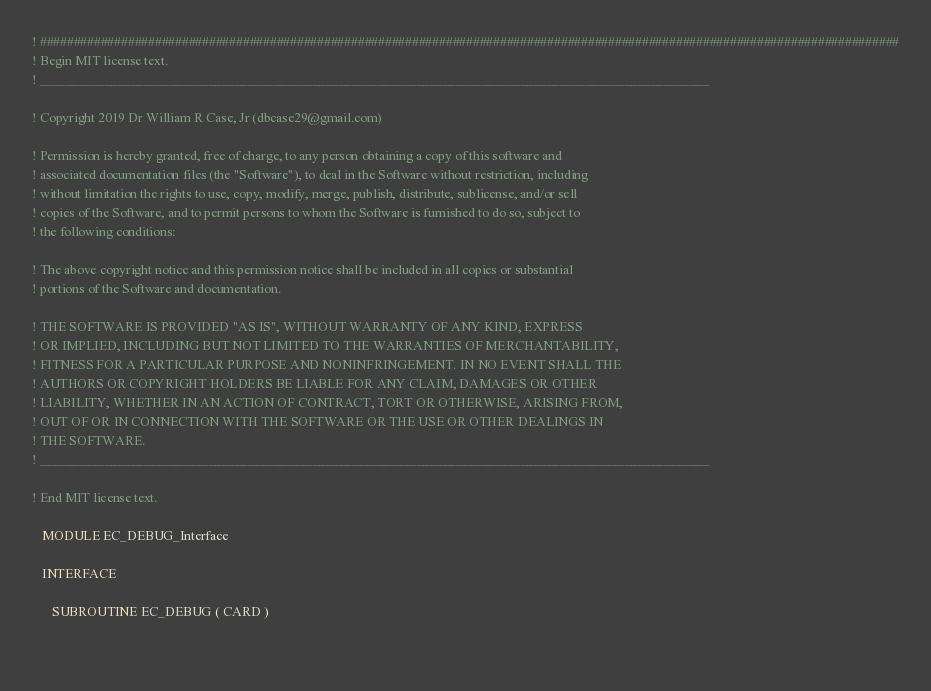Convert code to text. <code><loc_0><loc_0><loc_500><loc_500><_FORTRAN_>! ###############################################################################################################################
! Begin MIT license text.                                                                                    
! _______________________________________________________________________________________________________
                                                                                                         
! Copyright 2019 Dr William R Case, Jr (dbcase29@gmail.com)                                              
                                                                                                         
! Permission is hereby granted, free of charge, to any person obtaining a copy of this software and      
! associated documentation files (the "Software"), to deal in the Software without restriction, including
! without limitation the rights to use, copy, modify, merge, publish, distribute, sublicense, and/or sell
! copies of the Software, and to permit persons to whom the Software is furnished to do so, subject to   
! the following conditions:                                                                              
                                                                                                         
! The above copyright notice and this permission notice shall be included in all copies or substantial   
! portions of the Software and documentation.                                                                              
                                                                                                         
! THE SOFTWARE IS PROVIDED "AS IS", WITHOUT WARRANTY OF ANY KIND, EXPRESS                                
! OR IMPLIED, INCLUDING BUT NOT LIMITED TO THE WARRANTIES OF MERCHANTABILITY,                            
! FITNESS FOR A PARTICULAR PURPOSE AND NONINFRINGEMENT. IN NO EVENT SHALL THE                            
! AUTHORS OR COPYRIGHT HOLDERS BE LIABLE FOR ANY CLAIM, DAMAGES OR OTHER                                 
! LIABILITY, WHETHER IN AN ACTION OF CONTRACT, TORT OR OTHERWISE, ARISING FROM,                          
! OUT OF OR IN CONNECTION WITH THE SOFTWARE OR THE USE OR OTHER DEALINGS IN                              
! THE SOFTWARE.                                                                                          
! _______________________________________________________________________________________________________
                                                                                                        
! End MIT license text.                                                                                      

   MODULE EC_DEBUG_Interface

   INTERFACE

      SUBROUTINE EC_DEBUG ( CARD )

  </code> 